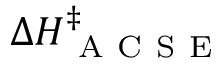Convert formula to latex. <formula><loc_0><loc_0><loc_500><loc_500>\Delta H _ { A C S E } ^ { \ddagger }</formula> 